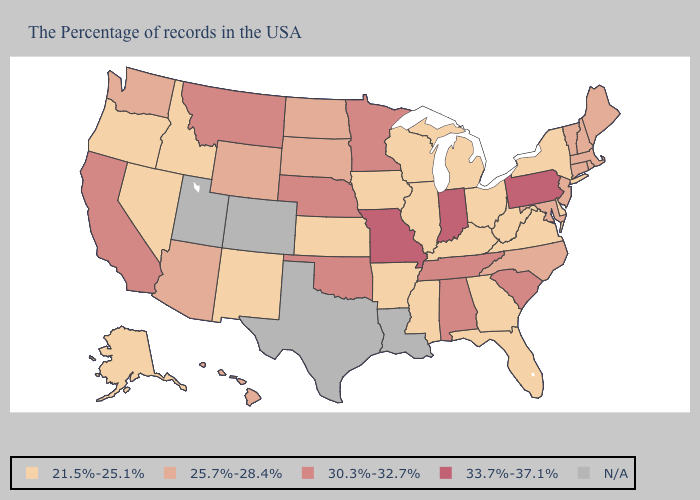What is the value of Maryland?
Give a very brief answer. 25.7%-28.4%. Does Ohio have the lowest value in the USA?
Write a very short answer. Yes. Name the states that have a value in the range 30.3%-32.7%?
Write a very short answer. South Carolina, Alabama, Tennessee, Minnesota, Nebraska, Oklahoma, Montana, California. What is the value of Montana?
Write a very short answer. 30.3%-32.7%. What is the value of Maryland?
Answer briefly. 25.7%-28.4%. What is the lowest value in the USA?
Quick response, please. 21.5%-25.1%. What is the highest value in states that border Ohio?
Answer briefly. 33.7%-37.1%. What is the lowest value in the USA?
Concise answer only. 21.5%-25.1%. Name the states that have a value in the range 30.3%-32.7%?
Quick response, please. South Carolina, Alabama, Tennessee, Minnesota, Nebraska, Oklahoma, Montana, California. Name the states that have a value in the range N/A?
Concise answer only. Louisiana, Texas, Colorado, Utah. Among the states that border North Carolina , does Georgia have the lowest value?
Short answer required. Yes. Name the states that have a value in the range 25.7%-28.4%?
Concise answer only. Maine, Massachusetts, Rhode Island, New Hampshire, Vermont, Connecticut, New Jersey, Maryland, North Carolina, South Dakota, North Dakota, Wyoming, Arizona, Washington, Hawaii. Which states have the highest value in the USA?
Write a very short answer. Pennsylvania, Indiana, Missouri. How many symbols are there in the legend?
Answer briefly. 5. 